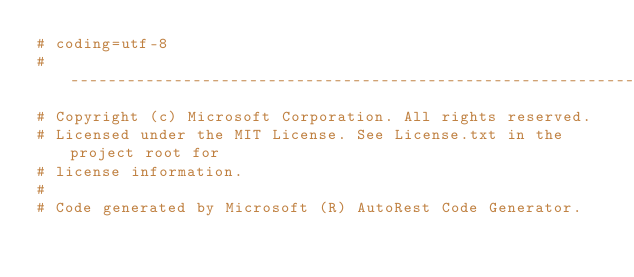<code> <loc_0><loc_0><loc_500><loc_500><_Python_># coding=utf-8
# --------------------------------------------------------------------------
# Copyright (c) Microsoft Corporation. All rights reserved.
# Licensed under the MIT License. See License.txt in the project root for
# license information.
#
# Code generated by Microsoft (R) AutoRest Code Generator.</code> 